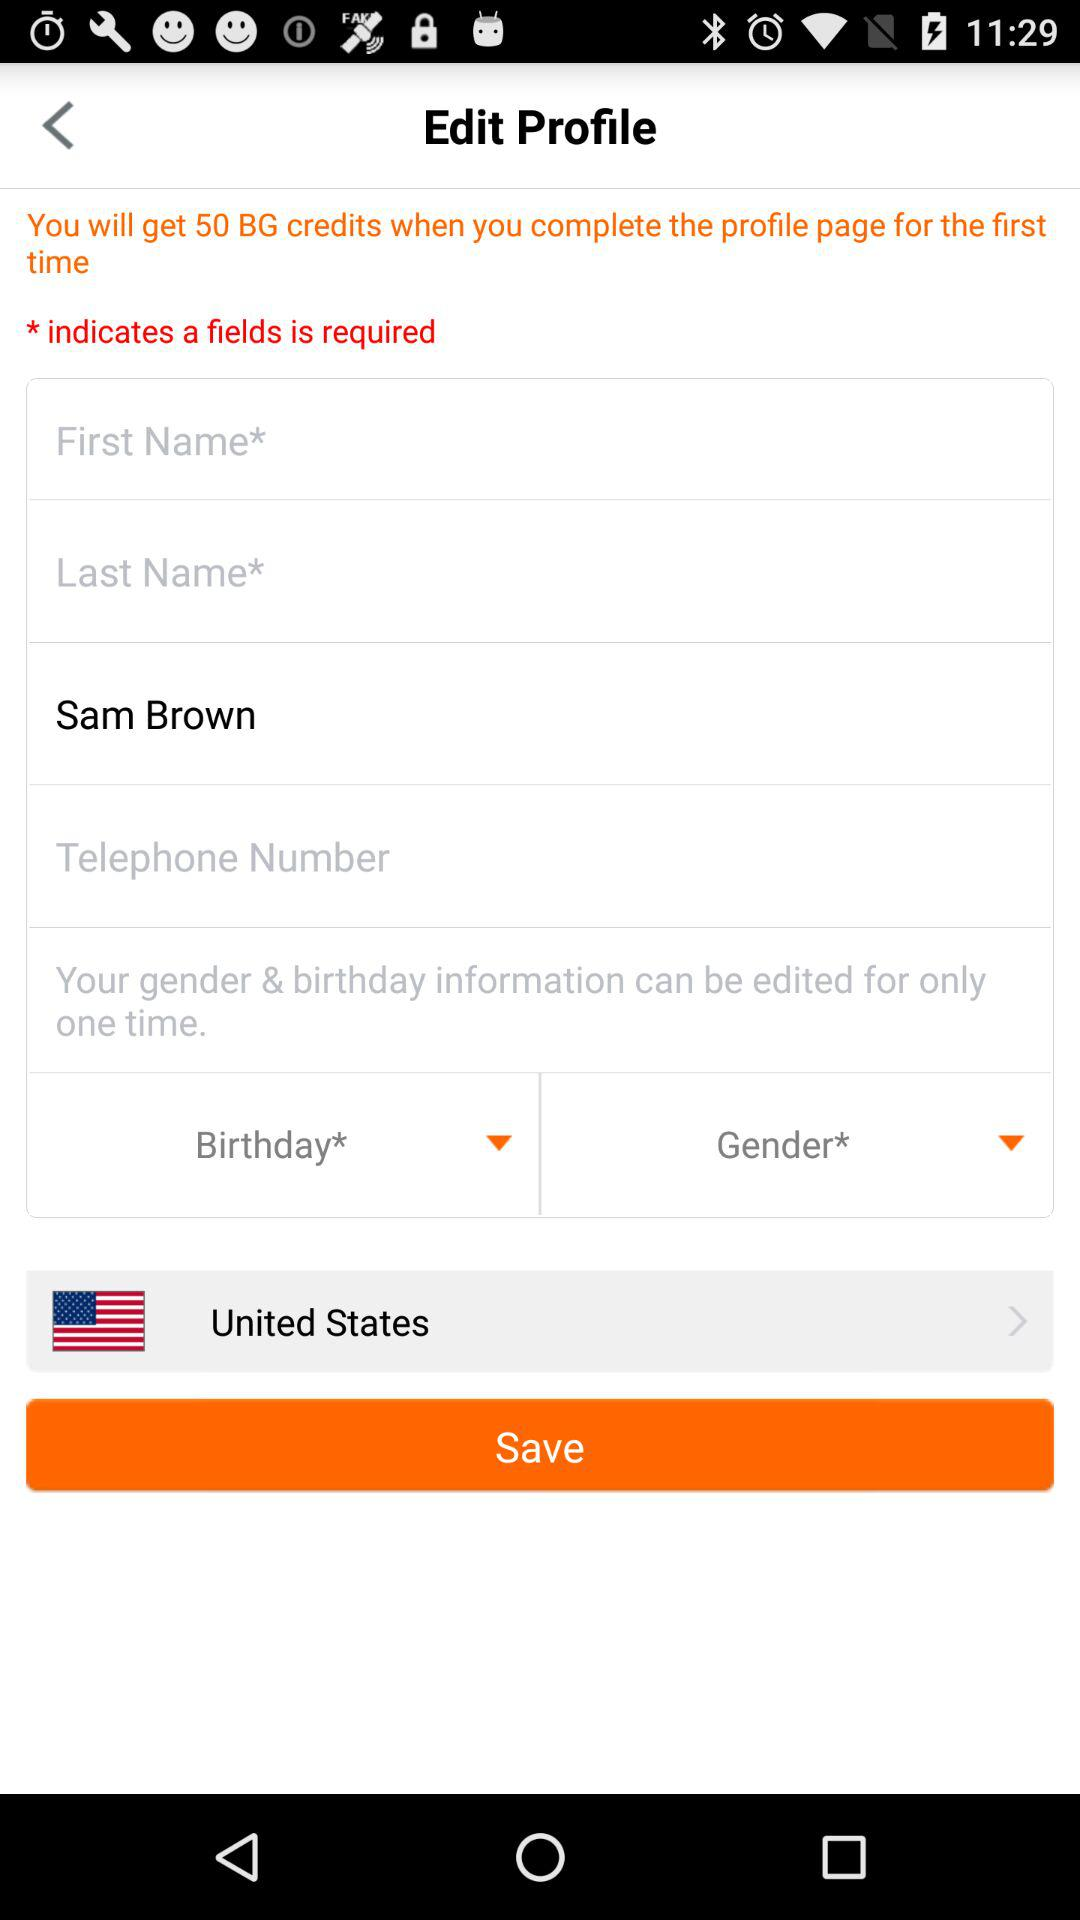What is the user's name? The user's name is Sam Brown. 